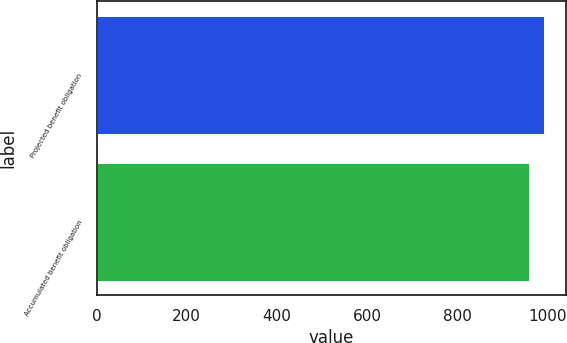<chart> <loc_0><loc_0><loc_500><loc_500><bar_chart><fcel>Projected benefit obligation<fcel>Accumulated benefit obligation<nl><fcel>993<fcel>960<nl></chart> 